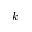Convert formula to latex. <formula><loc_0><loc_0><loc_500><loc_500>k</formula> 